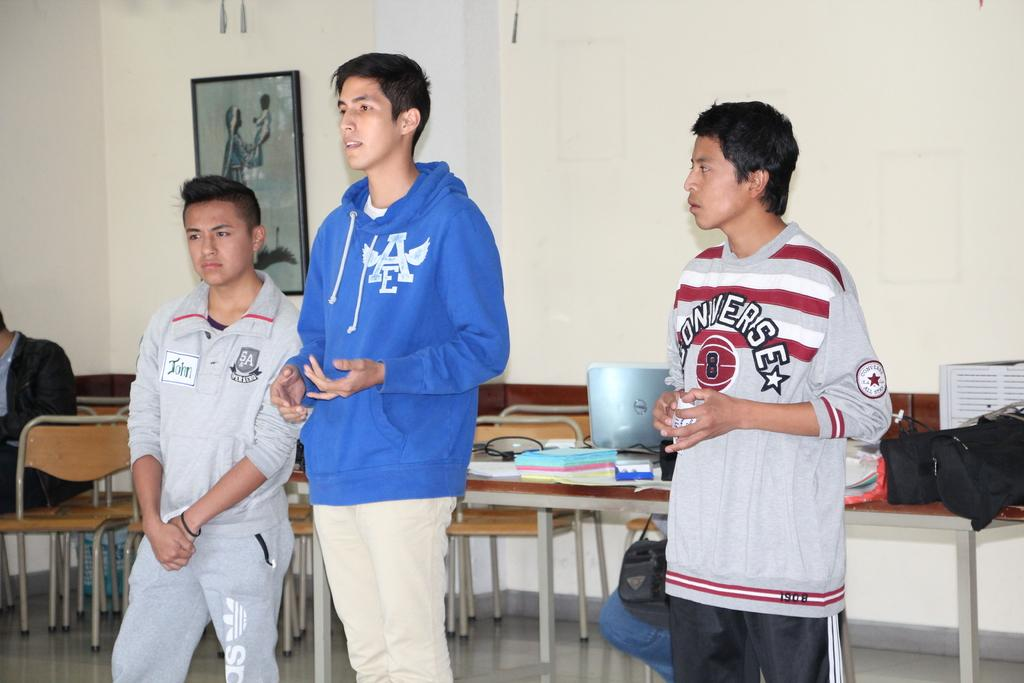Provide a one-sentence caption for the provided image. A boy in an AE hoodie stands between another boy in a converse shirt and boy in an SA shirt. 